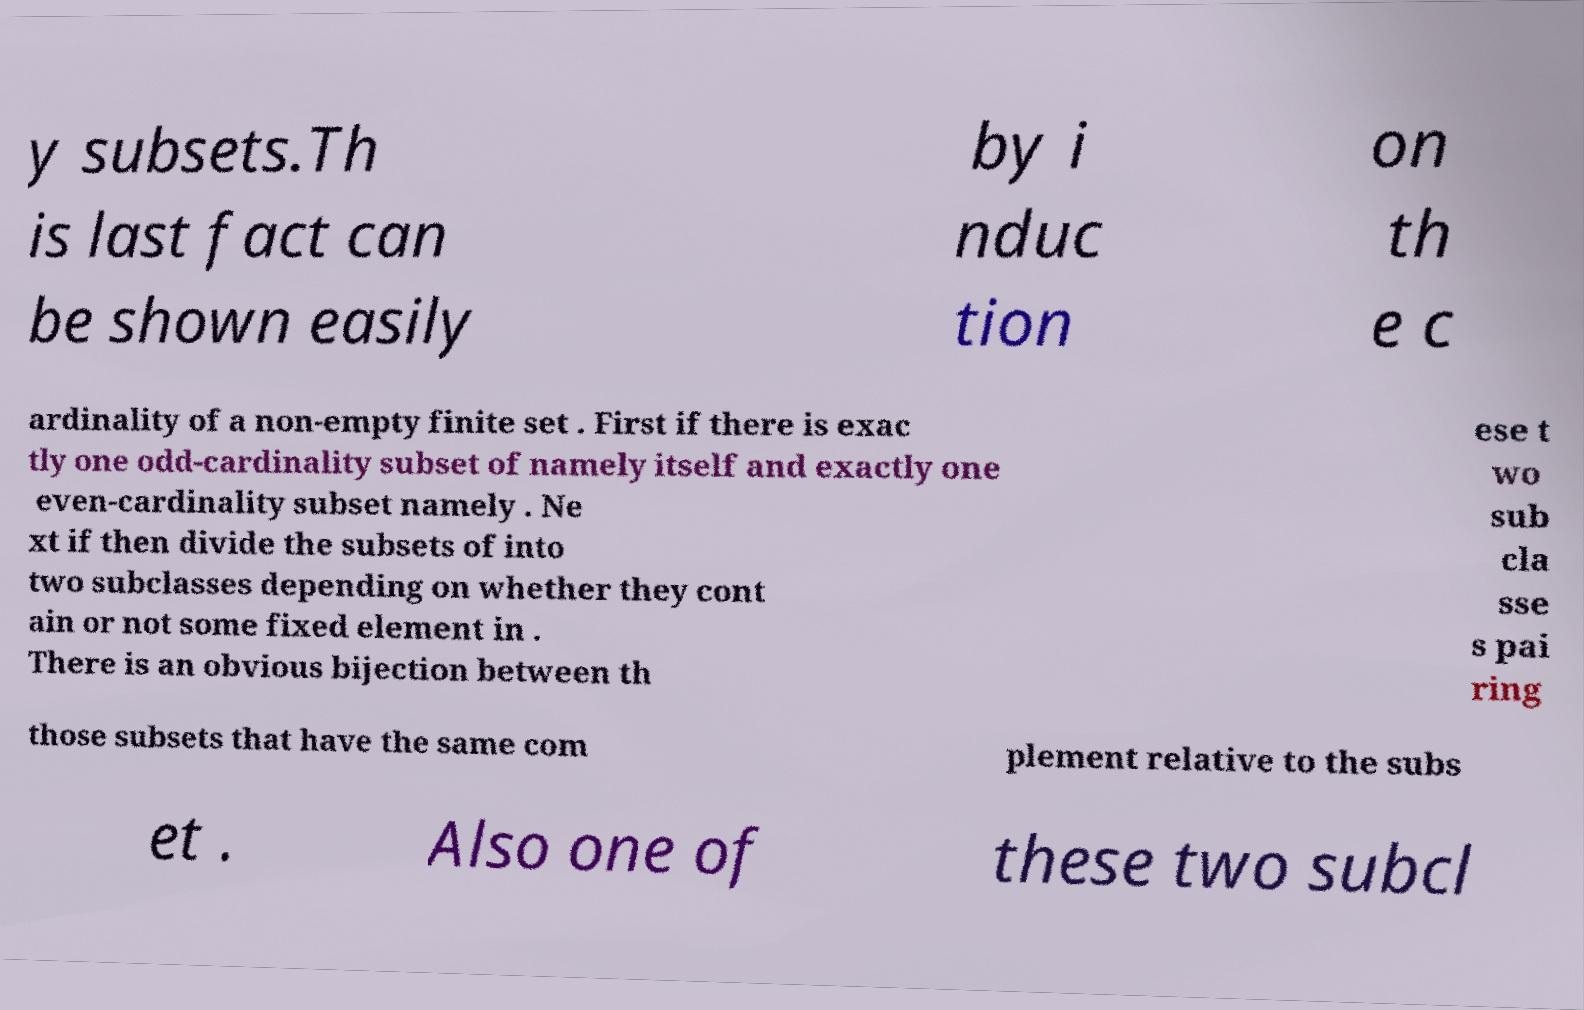Please read and relay the text visible in this image. What does it say? y subsets.Th is last fact can be shown easily by i nduc tion on th e c ardinality of a non-empty finite set . First if there is exac tly one odd-cardinality subset of namely itself and exactly one even-cardinality subset namely . Ne xt if then divide the subsets of into two subclasses depending on whether they cont ain or not some fixed element in . There is an obvious bijection between th ese t wo sub cla sse s pai ring those subsets that have the same com plement relative to the subs et . Also one of these two subcl 